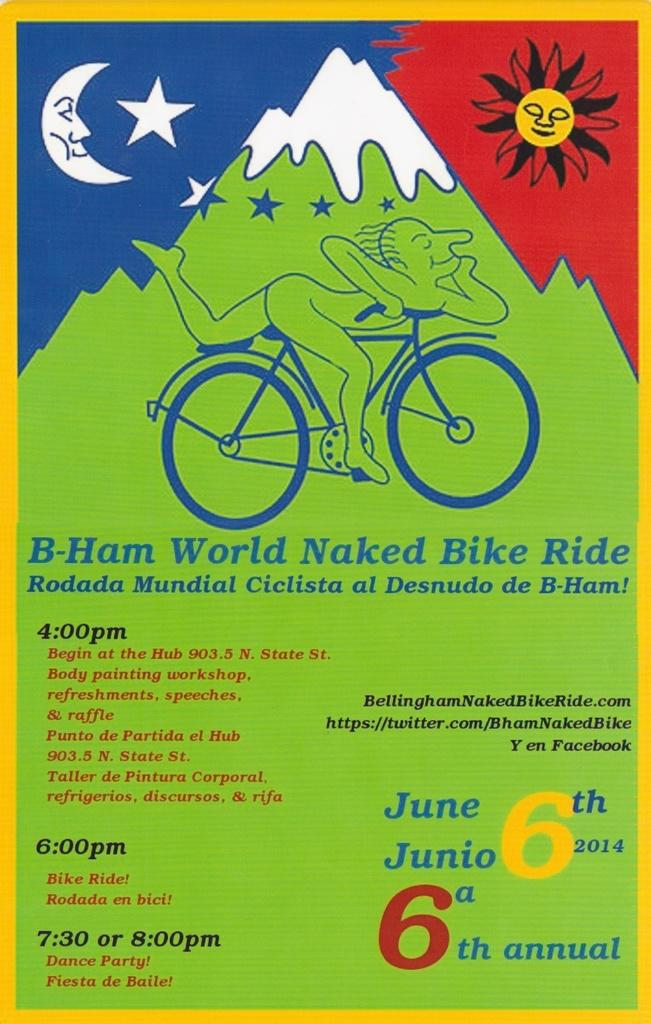Provide a one-sentence caption for the provided image. a green red and blue poster for the World Naked Bike Ride. 